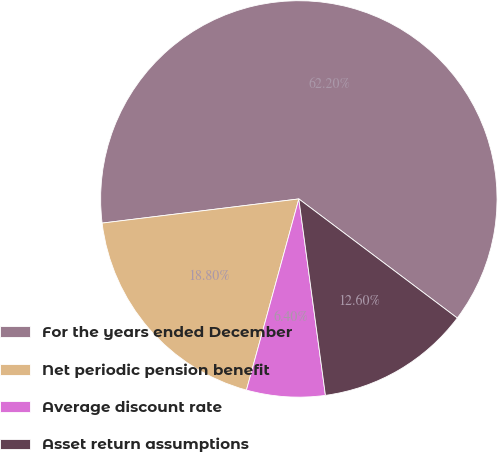Convert chart to OTSL. <chart><loc_0><loc_0><loc_500><loc_500><pie_chart><fcel>For the years ended December<fcel>Net periodic pension benefit<fcel>Average discount rate<fcel>Asset return assumptions<nl><fcel>62.21%<fcel>18.8%<fcel>6.4%<fcel>12.6%<nl></chart> 